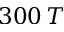Convert formula to latex. <formula><loc_0><loc_0><loc_500><loc_500>3 0 0 \, T</formula> 